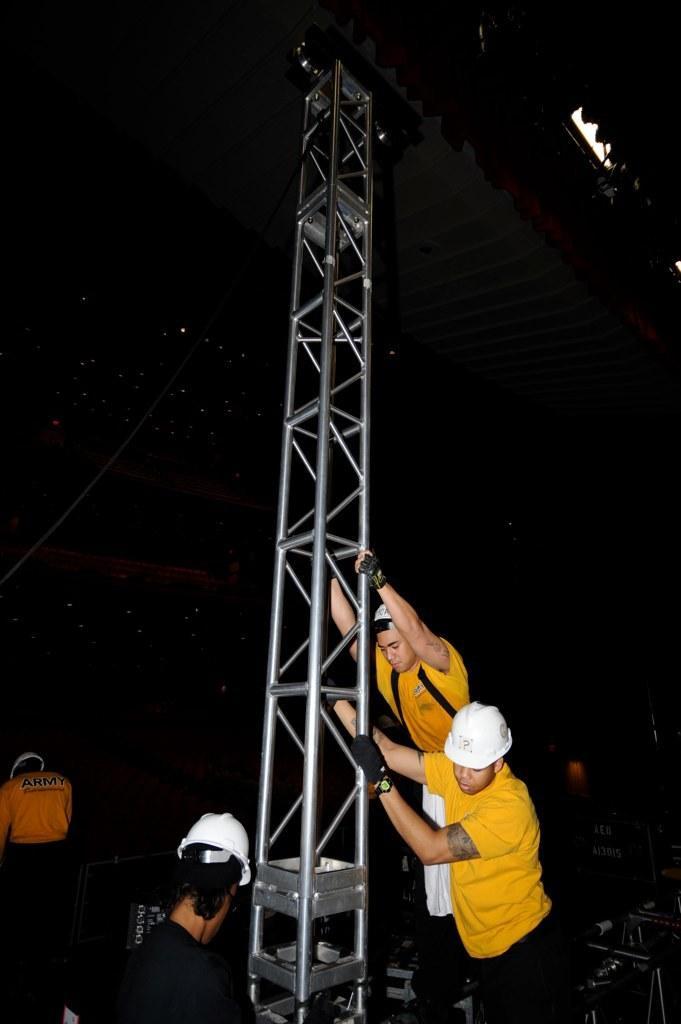In one or two sentences, can you explain what this image depicts? In this picture there are three persons holding a pole. They are wearing t-shirt and helmets. On the top right we can see the focus lights. 